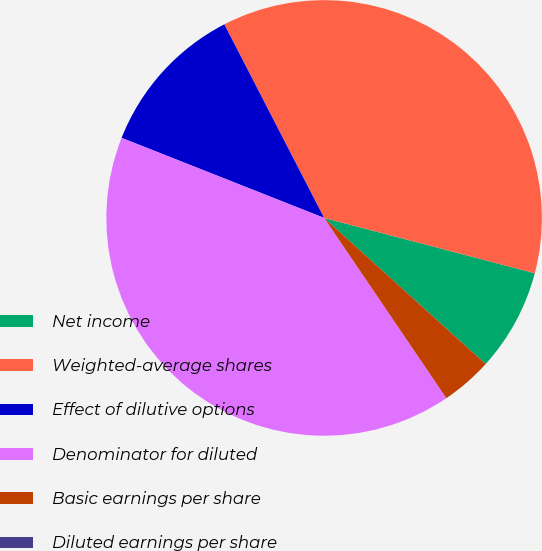Convert chart to OTSL. <chart><loc_0><loc_0><loc_500><loc_500><pie_chart><fcel>Net income<fcel>Weighted-average shares<fcel>Effect of dilutive options<fcel>Denominator for diluted<fcel>Basic earnings per share<fcel>Diluted earnings per share<nl><fcel>7.62%<fcel>36.66%<fcel>11.43%<fcel>40.47%<fcel>3.81%<fcel>0.0%<nl></chart> 